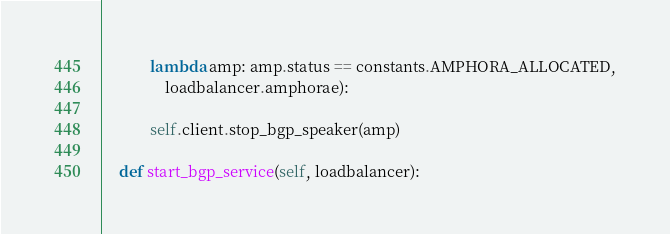Convert code to text. <code><loc_0><loc_0><loc_500><loc_500><_Python_>            lambda amp: amp.status == constants.AMPHORA_ALLOCATED,
                loadbalancer.amphorae):

            self.client.stop_bgp_speaker(amp)

    def start_bgp_service(self, loadbalancer):</code> 